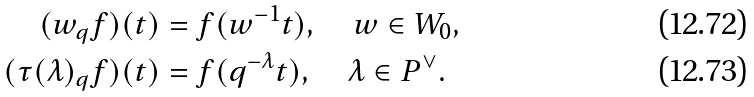Convert formula to latex. <formula><loc_0><loc_0><loc_500><loc_500>( w _ { q } f ) ( t ) & = f ( w ^ { - 1 } t ) , \quad w \in W _ { 0 } , \\ ( \tau ( \lambda ) _ { q } f ) ( t ) & = f ( q ^ { - \lambda } t ) , \quad \lambda \in P ^ { \vee } .</formula> 